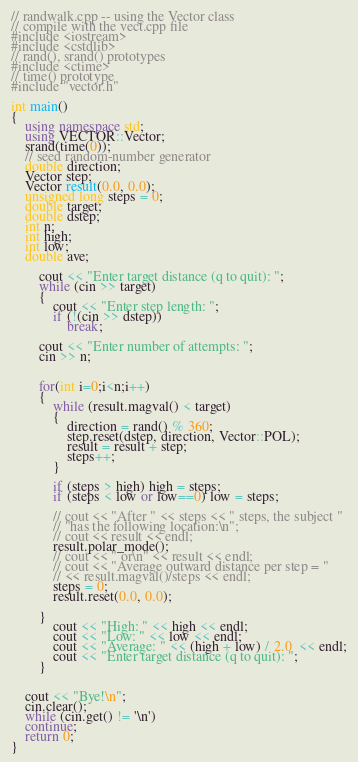Convert code to text. <code><loc_0><loc_0><loc_500><loc_500><_C++_>// randwalk.cpp -- using the Vector class
// compile with the vect.cpp file
#include <iostream>
#include <cstdlib>
// rand(), srand() prototypes
#include <ctime>
// time() prototype
#include "vector.h"

int main()
{
	using namespace std;
	using VECTOR::Vector;
	srand(time(0));
	// seed random-number generator
	double direction;
	Vector step;
	Vector result(0.0, 0.0);
	unsigned long steps = 0;
	double target;
	double dstep;
	int n;
	int high;
	int low;
	double ave;

		cout << "Enter target distance (q to quit): ";
		while (cin >> target)
		{
			cout << "Enter step length: ";
			if (!(cin >> dstep))
				break;

		cout << "Enter number of attempts: ";
		cin >> n;


		for(int i=0;i<n;i++)
		{
			while (result.magval() < target)
			{
				direction = rand() % 360;
				step.reset(dstep, direction, Vector::POL);
				result = result + step;
				steps++;
			}
			
			if (steps > high) high = steps;
			if (steps < low or low==0) low = steps;

			// cout << "After " << steps << " steps, the subject "
			// "has the following location:\n";
			// cout << result << endl;
			result.polar_mode();
			// cout << " or\n" << result << endl;
			// cout << "Average outward distance per step = "
			// << result.magval()/steps << endl;
			steps = 0;
			result.reset(0.0, 0.0);

		}
			cout << "High: " << high << endl;
			cout << "Low: " << low << endl;
			cout << "Average: " << (high + low) / 2.0  << endl;
			cout << "Enter target distance (q to quit): ";
		}

	
	cout << "Bye!\n";
	cin.clear();
	while (cin.get() != '\n')
	continue;
	return 0;
}</code> 